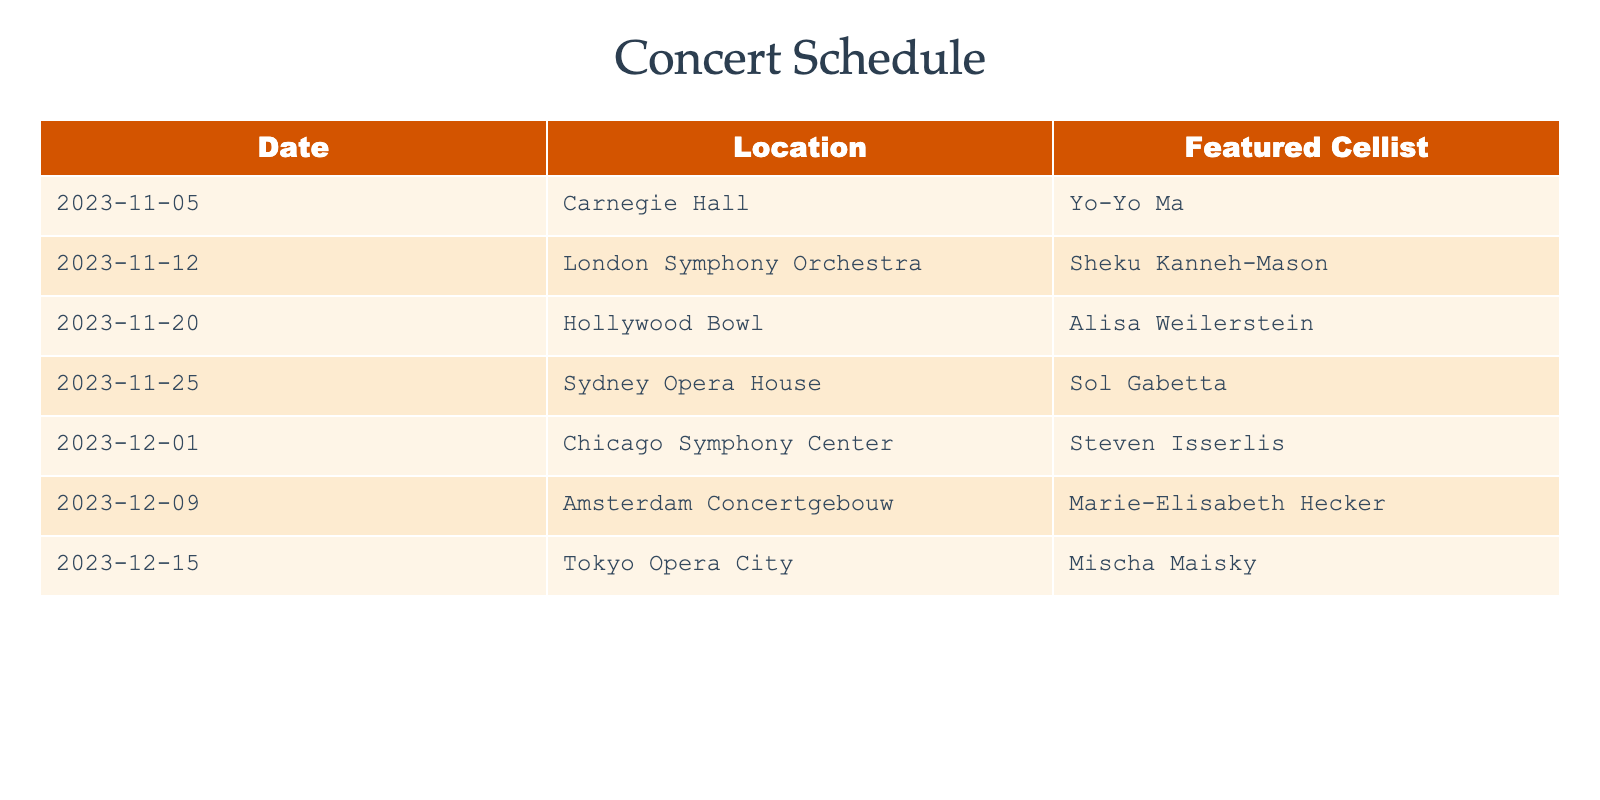What is the date of the concert featuring Yo-Yo Ma? The table shows that Yo-Yo Ma is featured at Carnegie Hall on the date 2023-11-05.
Answer: 2023-11-05 Which cellist is performing at the Sydney Opera House? According to the table, Sol Gabetta is the featured cellist for the concert at the Sydney Opera House.
Answer: Sol Gabetta How many concerts are scheduled in December 2023? The table lists three concerts in December: on December 1, 9, and 15, which totals to three concerts.
Answer: 3 Is Marie-Elisabeth Hecker performing at a concert in November? Looking at the dates in the table, Marie-Elisabeth Hecker is scheduled to perform on December 9, 2023, therefore she is not performing in November.
Answer: No Which location features the concert with the earliest date? The earliest date listed in the table is 2023-11-05 at Carnegie Hall, thus it features the concert with the earliest date.
Answer: Carnegie Hall What is the difference in the number of days between the concerts featuring Sheku Kanneh-Mason and Steven Isserlis? Sheku Kanneh-Mason’s concert is on November 12 and Steven Isserlis’ is on December 1. The difference in days is calculated as follows: December 1 - November 12 = 19 days.
Answer: 19 days Are there any concerts at the Tokyo Opera City in November? According to the table, the concert at Tokyo Opera City is scheduled for December 15, so there are no concerts there in November.
Answer: No Which featured cellist has the concert at the Amsterdam Concertgebouw? The table indicates that Marie-Elisabeth Hecker is the featured cellist at the Amsterdam Concertgebouw on December 9, 2023.
Answer: Marie-Elisabeth Hecker What is the total number of concerts listed in the table? The table contains a total of seven concerts scheduled. This is counted by the number of rows in the data.
Answer: 7 